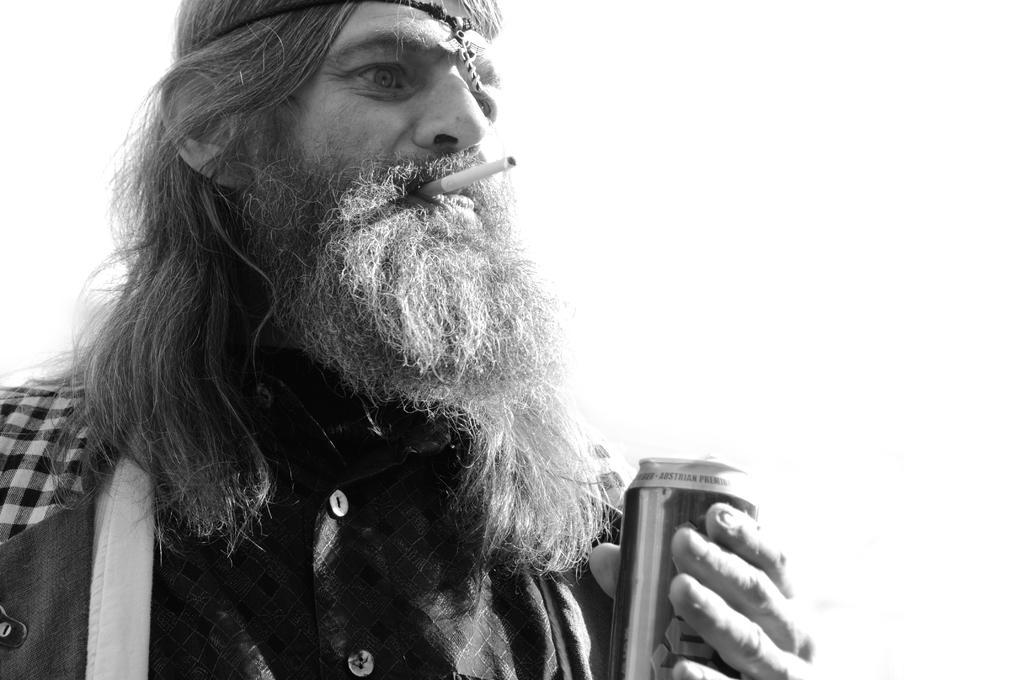Please provide a concise description of this image. In the image we can see there is a person standing and he is holding a juice can and a cigarette in his mouth. 